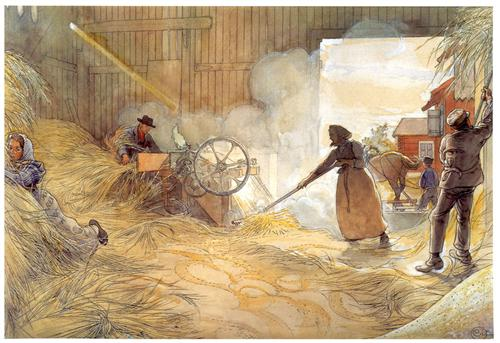Imagine you are one of the workers in the painting. Describe your day from your perspective. As one of the workers in the painting, my day begins before the sun has fully risen. The crisp morning air fills the barn as I prepare the threshing machine and gather the necessary tools. Soon, others arrive, and we exchange brief greetings before diving into our tasks. The sounds of grain being threshed and the chatter of my colleagues create a familiar symphony. My muscles strain as I wield the flail, but the repetitive motion becomes meditative. By mid-day, we share a simple meal, exchanging stories and laughter. The afternoon continues with a steady pace of work, punctuated by moments where I pause to wipe the sweat from my brow and glance at the progress we've made. As the day winds down, a sense of accomplishment and pride fills me. The setting sun casts a golden light inside the barn, and I take a moment to appreciate the beauty of our shared labor before heading home, tired but content. 